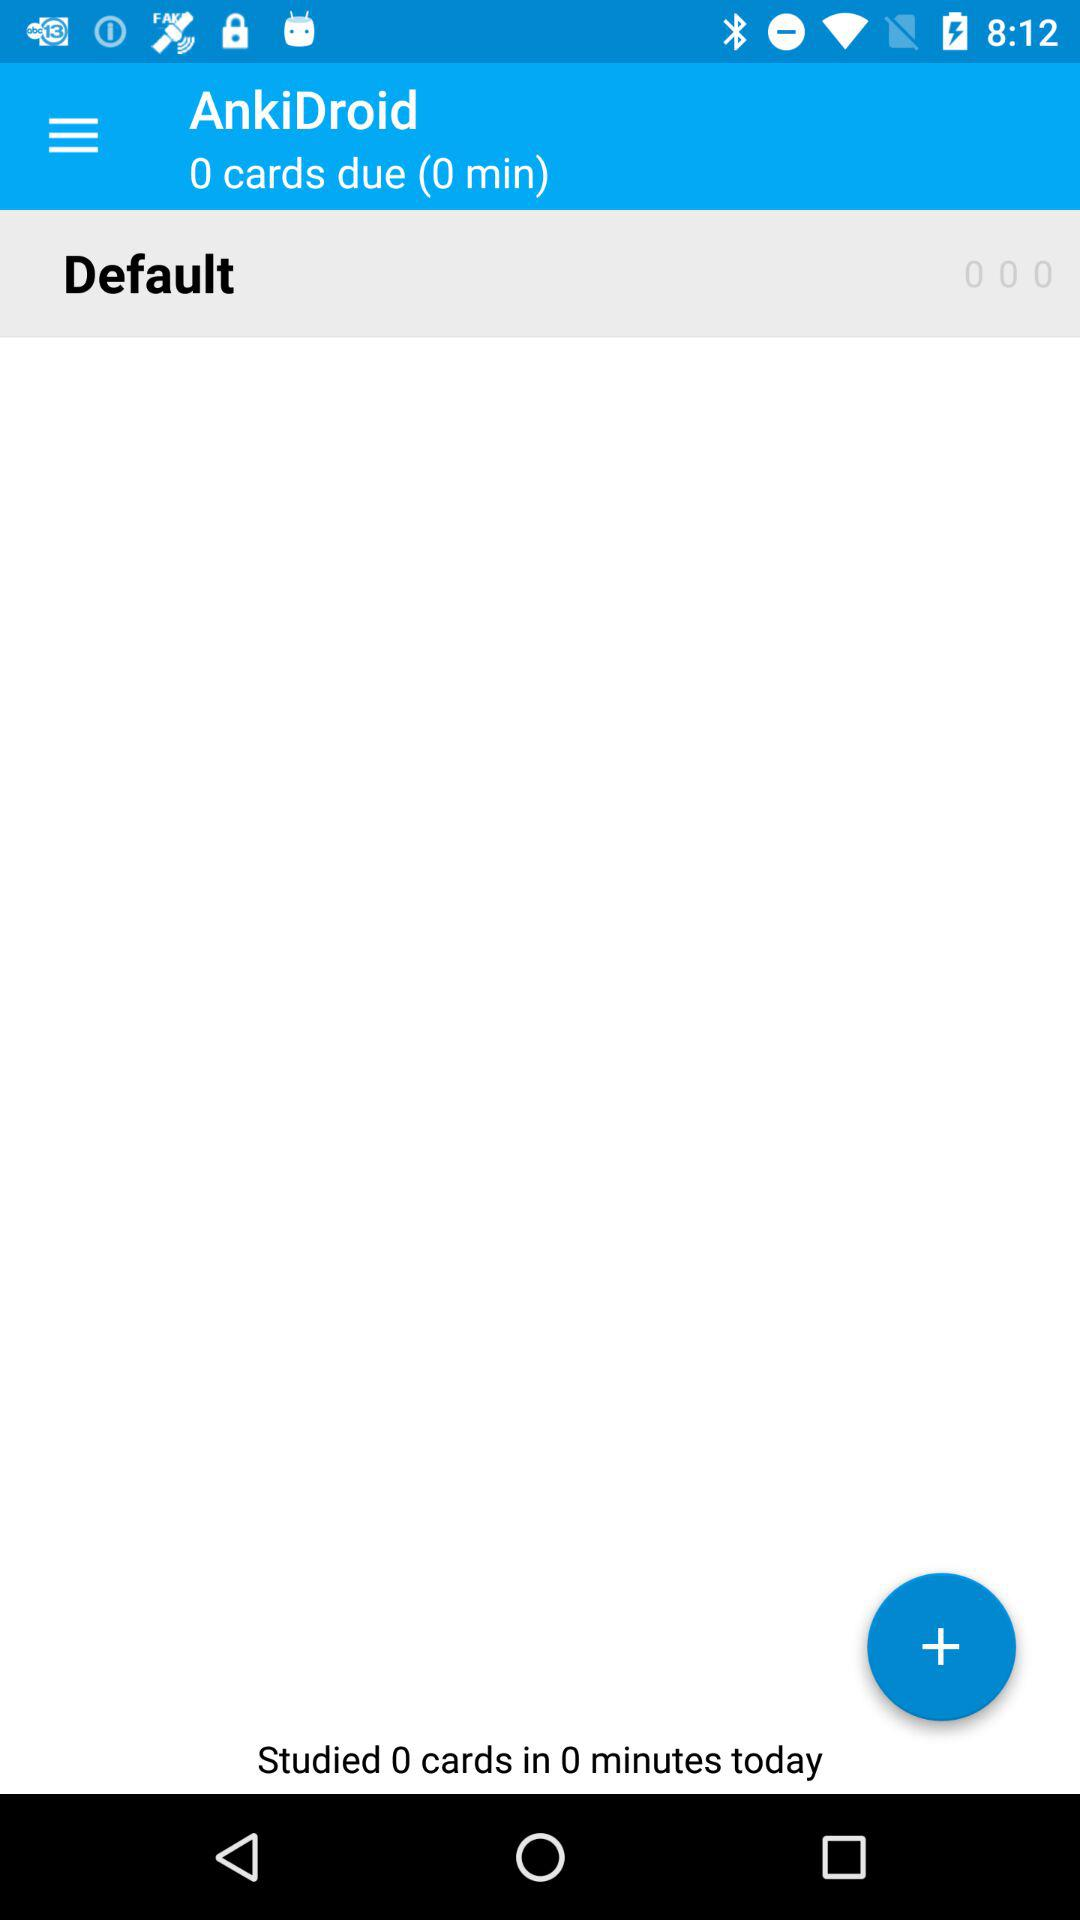What is the name of the application? The name of the application is "AnkiDroid". 